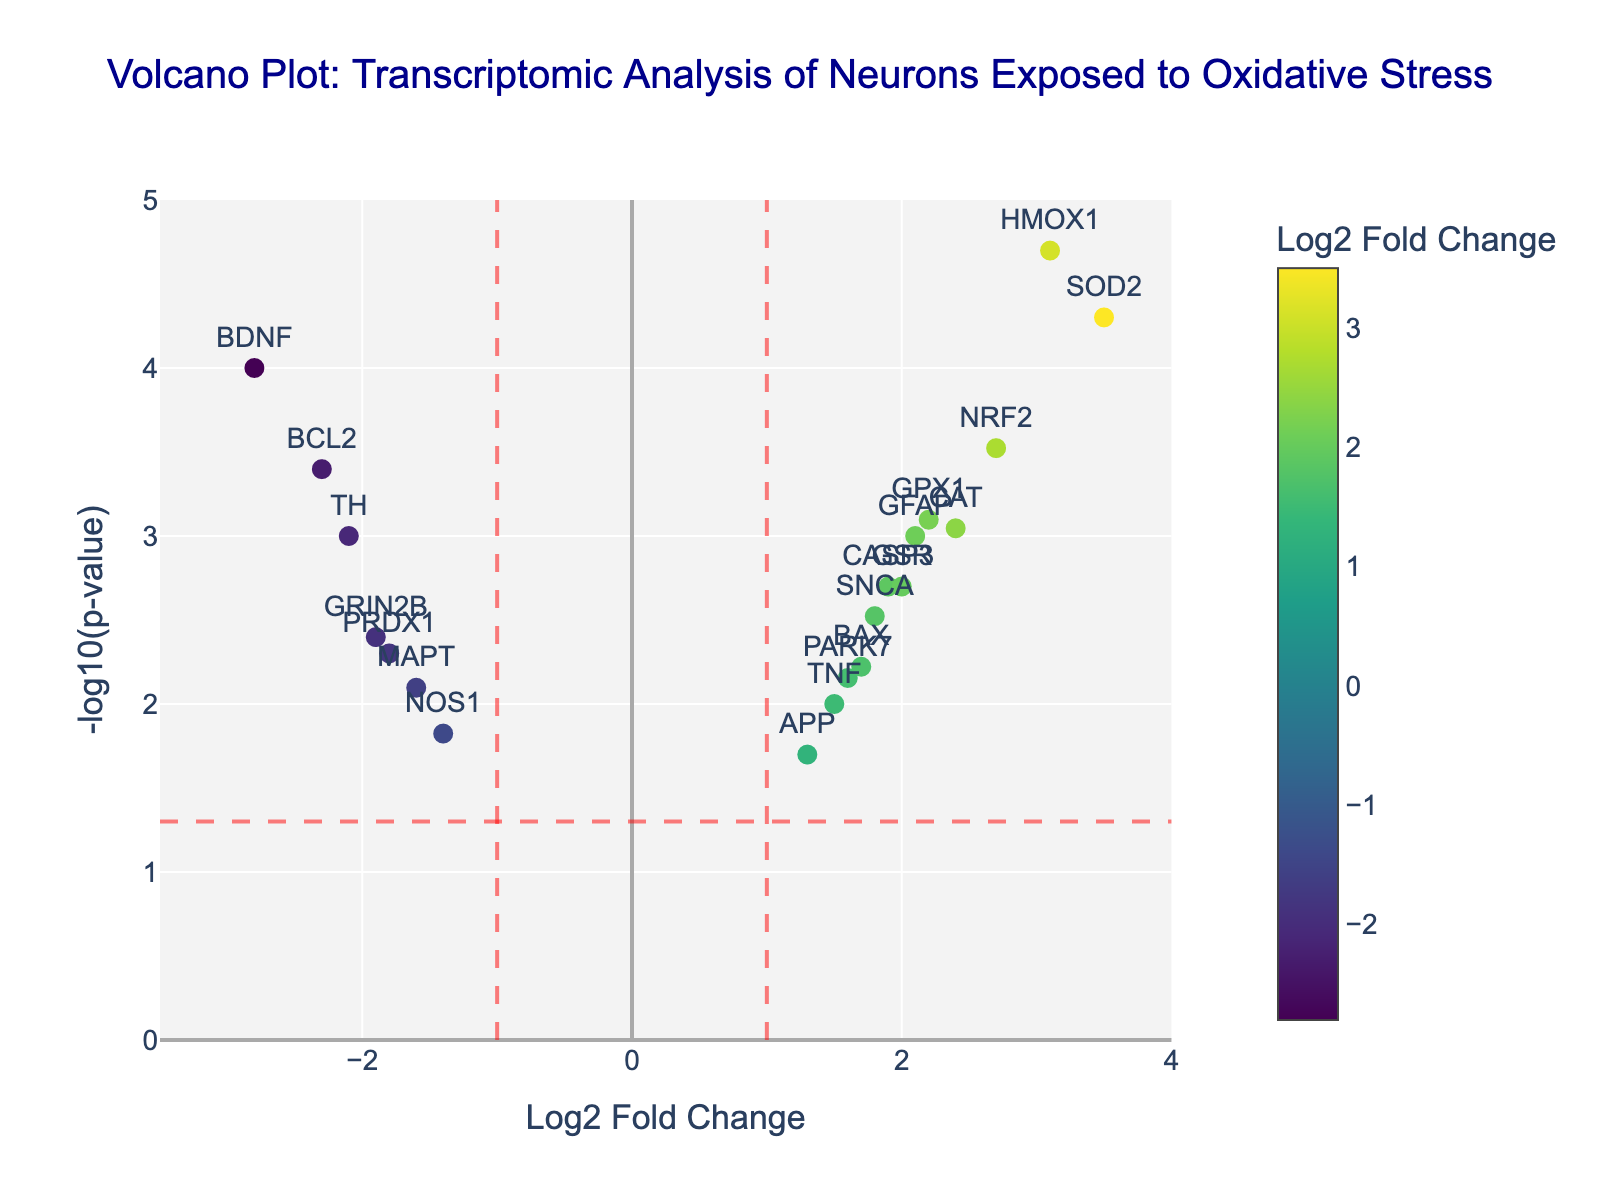How many genes are significantly up-regulated? To determine the number of significantly up-regulated genes, look for points that are on the right side of the vertical line at Log2 Fold Change = 1 and above the horizontal significance threshold at -log10(p-value) = 1.3.
Answer: 8 Which gene has the highest -log10(p-value)? By examining the y-axis for -log10(p-value) and identifying the point that is highest up, we see that the gene HMOX1 has the highest -log10(p-value).
Answer: HMOX1 What is the Log2 Fold Change and -log10(p-value) for the gene BDNF? Locate the point labeled BDNF on the plot and identify its coordinates on the x-axis (Log2 Fold Change) and the y-axis (-log10(p-value)).
Answer: -2.8, 4 Are there more up-regulated or down-regulated genes that are statistically significant? Count the number of significant genes (those above the horizontal significance threshold) on both sides of the vertical lines at Log2 Fold Change = 1 (up-regulated) and Log2 Fold Change = -1 (down-regulated). Compare the counts.
Answer: More up-regulated What range of -log10(p-value) is represented on the y-axis? Evaluate the y-axis from the bottom to the top to determine the lowest and highest values.
Answer: 0 to 5 Which gene has the highest Log2 Fold Change? Identify the point that is furthest to the right on the x-axis; this indicates the highest Log2 Fold Change.
Answer: SOD2 How does the response of BCL2 compare to that of BDNF in terms of fold change and significance? Compare the x-axis (Log2 Fold Change) and y-axis (-log10(p-value)) values of BCL2 and BDNF. Notice that BDNF has a more extreme negative fold change, while BCL2 is also down-regulated but with a slightly less negative fold change. Both have significant p-values, but BDNF appears more significant.
Answer: BDNF is more down-regulated and significant Which gene is the closest to the horizontal threshold but is not significant? Identify genes whose points are close to but below the horizontal line at -log10(p-value) = 1.3, meaning they are not statistically significant.
Answer: NOS1 What color indicates the highest Log2 Fold Change? Inspect the color scale bar and its alignment with the points to determine which color represents the highest Log2 Fold Change.
Answer: Yellow How many down-regulated genes are there with a Log2 Fold Change less than -2? Count the number of points located to the left of the vertical line at Log2 Fold Change = -2 and above the horizontal line at -log10(p-value) = 1.3.
Answer: 2 